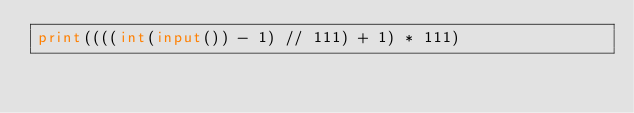<code> <loc_0><loc_0><loc_500><loc_500><_Python_>print((((int(input()) - 1) // 111) + 1) * 111)
</code> 